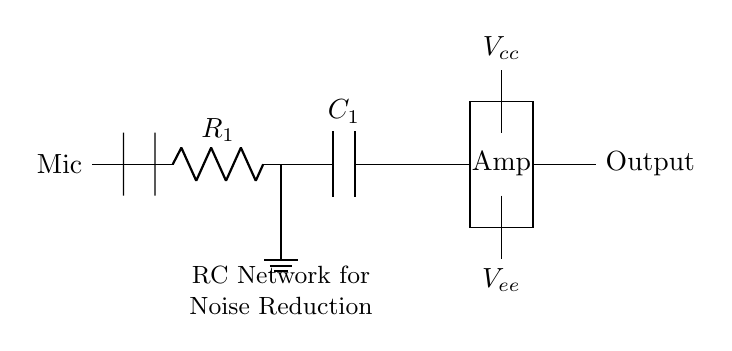What is the type of circuit shown? The circuit is an RC network, consisting of a resistor and a capacitor used for noise reduction in microphone preamplifiers.
Answer: RC network What component follows the RC network? The component following the RC network is an amplifier, as indicated by the label near the rectangular shape.
Answer: Amplifier What is the value of the resistor characterized as R1? The diagram does not specify a numerical value for the resistor R1, only its designation, hence it's indeterminate from this circuit alone.
Answer: Indeterminate What does the capacitor labeled C1 do in this circuit? The capacitor C1 is part of the noise reduction mechanism, filtering out high-frequency noise and allowing the desired audio signal to pass through.
Answer: Filters noise How does the RC network affect the signal? The RC network provides a low-pass filter effect, attenuating high-frequency noise while allowing lower frequencies from the microphone signal to reach the amplifier.
Answer: Attenuates high frequencies What is the function of the ground connection in this circuit? The ground connection provides a reference point for the other voltages in the circuit and helps stabilize the operation of the entire circuit by completing the electrical path.
Answer: Reference point How is the RC network connected to the rest of the circuit? The RC network is connected in series between the microphone output and the amplifier input, allowing the microphone signal to flow through it before reaching the amplifier.
Answer: In series with the amplifier 